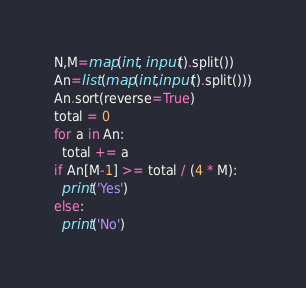<code> <loc_0><loc_0><loc_500><loc_500><_Python_>N,M=map(int, input().split())
An=list(map(int,input().split()))
An.sort(reverse=True)
total = 0
for a in An:
  total += a
if An[M-1] >= total / (4 * M):
  print('Yes')
else:
  print('No')


</code> 